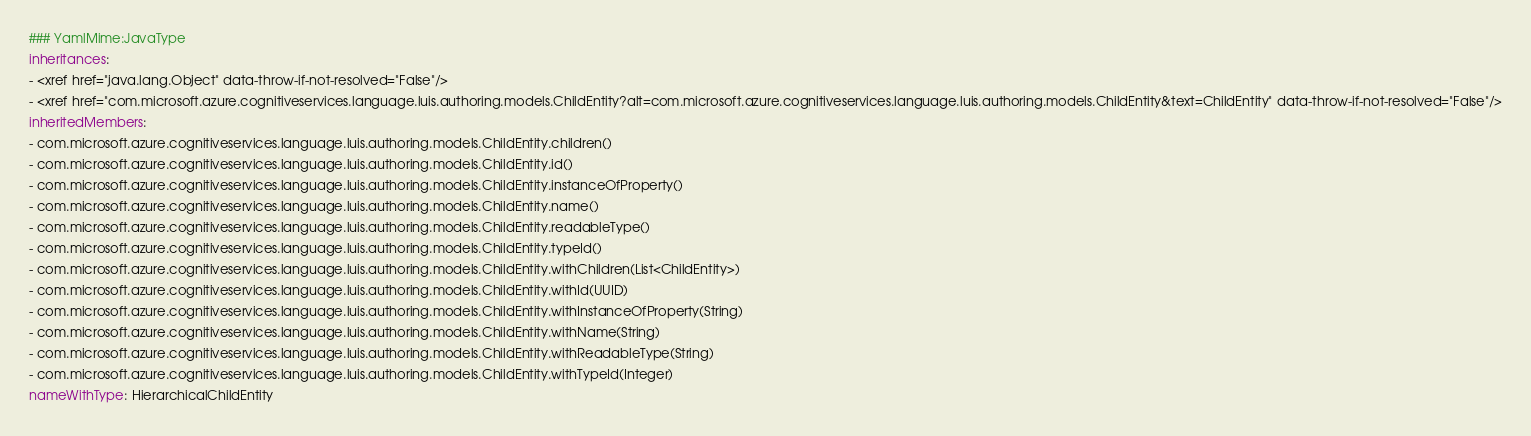Convert code to text. <code><loc_0><loc_0><loc_500><loc_500><_YAML_>### YamlMime:JavaType
inheritances:
- <xref href="java.lang.Object" data-throw-if-not-resolved="False"/>
- <xref href="com.microsoft.azure.cognitiveservices.language.luis.authoring.models.ChildEntity?alt=com.microsoft.azure.cognitiveservices.language.luis.authoring.models.ChildEntity&text=ChildEntity" data-throw-if-not-resolved="False"/>
inheritedMembers:
- com.microsoft.azure.cognitiveservices.language.luis.authoring.models.ChildEntity.children()
- com.microsoft.azure.cognitiveservices.language.luis.authoring.models.ChildEntity.id()
- com.microsoft.azure.cognitiveservices.language.luis.authoring.models.ChildEntity.instanceOfProperty()
- com.microsoft.azure.cognitiveservices.language.luis.authoring.models.ChildEntity.name()
- com.microsoft.azure.cognitiveservices.language.luis.authoring.models.ChildEntity.readableType()
- com.microsoft.azure.cognitiveservices.language.luis.authoring.models.ChildEntity.typeId()
- com.microsoft.azure.cognitiveservices.language.luis.authoring.models.ChildEntity.withChildren(List<ChildEntity>)
- com.microsoft.azure.cognitiveservices.language.luis.authoring.models.ChildEntity.withId(UUID)
- com.microsoft.azure.cognitiveservices.language.luis.authoring.models.ChildEntity.withInstanceOfProperty(String)
- com.microsoft.azure.cognitiveservices.language.luis.authoring.models.ChildEntity.withName(String)
- com.microsoft.azure.cognitiveservices.language.luis.authoring.models.ChildEntity.withReadableType(String)
- com.microsoft.azure.cognitiveservices.language.luis.authoring.models.ChildEntity.withTypeId(Integer)
nameWithType: HierarchicalChildEntity</code> 